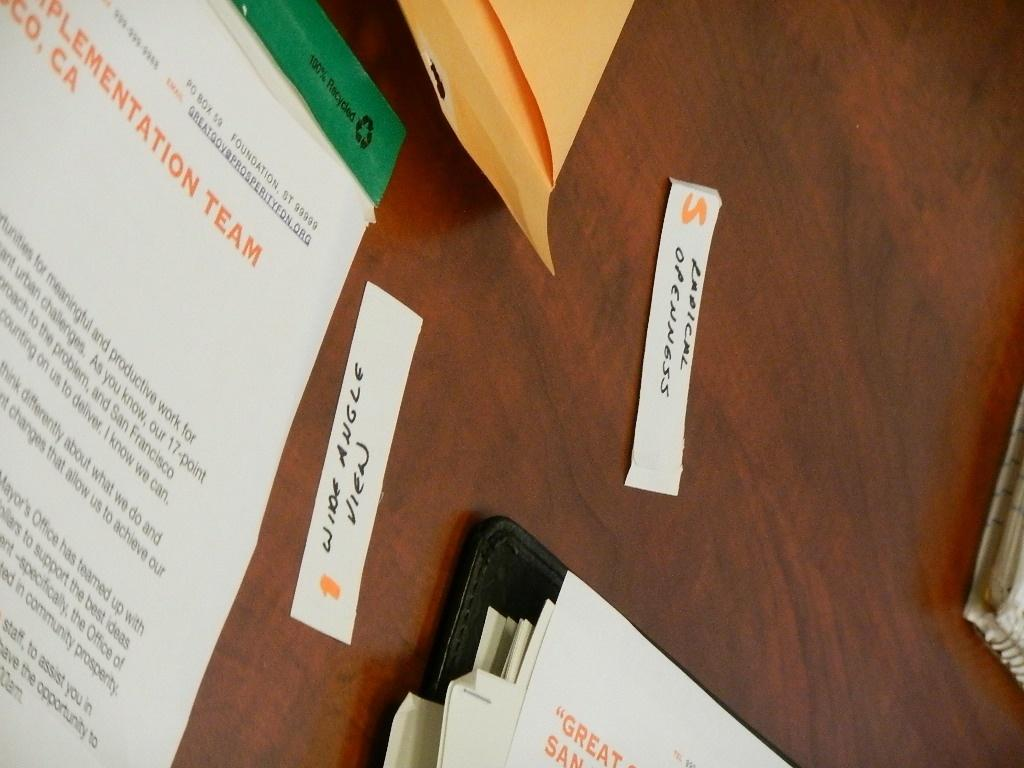<image>
Render a clear and concise summary of the photo. a table with some papers on it with one that says 'great' 